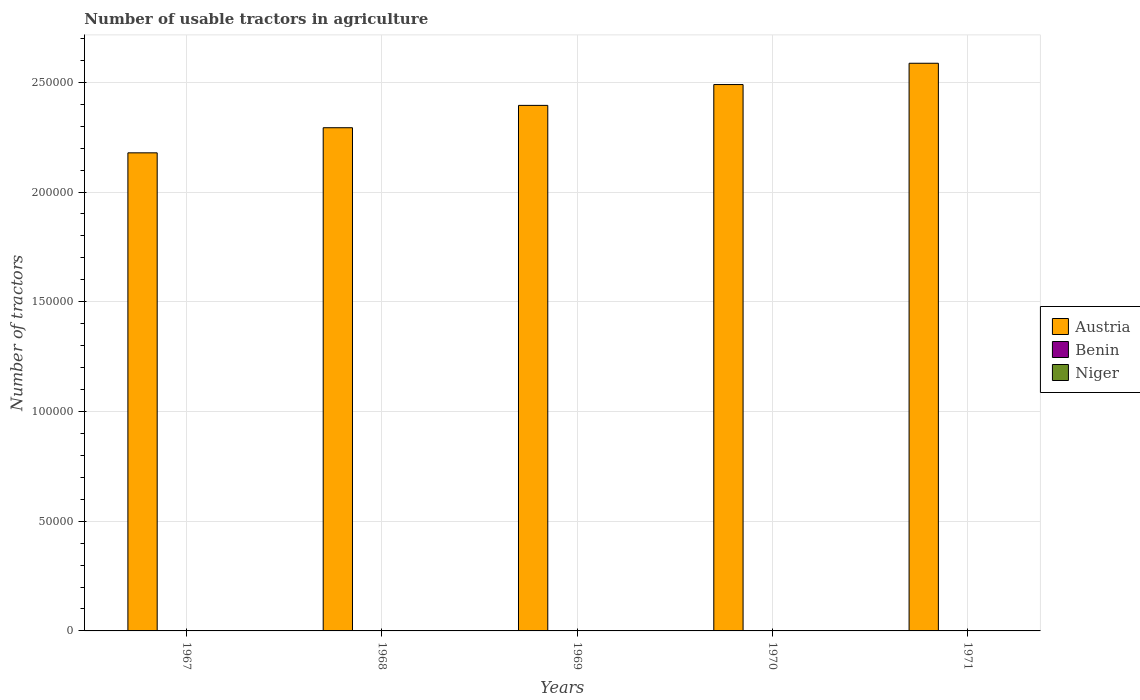How many groups of bars are there?
Make the answer very short. 5. Are the number of bars on each tick of the X-axis equal?
Your answer should be compact. Yes. How many bars are there on the 3rd tick from the right?
Give a very brief answer. 3. In how many cases, is the number of bars for a given year not equal to the number of legend labels?
Offer a very short reply. 0. What is the number of usable tractors in agriculture in Austria in 1969?
Ensure brevity in your answer.  2.39e+05. Across all years, what is the minimum number of usable tractors in agriculture in Austria?
Provide a short and direct response. 2.18e+05. In which year was the number of usable tractors in agriculture in Austria maximum?
Provide a short and direct response. 1971. In which year was the number of usable tractors in agriculture in Austria minimum?
Offer a very short reply. 1967. What is the total number of usable tractors in agriculture in Austria in the graph?
Give a very brief answer. 1.19e+06. What is the difference between the number of usable tractors in agriculture in Niger in 1969 and that in 1971?
Give a very brief answer. -46. What is the difference between the number of usable tractors in agriculture in Austria in 1969 and the number of usable tractors in agriculture in Benin in 1967?
Offer a very short reply. 2.39e+05. What is the average number of usable tractors in agriculture in Austria per year?
Your answer should be very brief. 2.39e+05. In the year 1969, what is the difference between the number of usable tractors in agriculture in Benin and number of usable tractors in agriculture in Austria?
Provide a short and direct response. -2.39e+05. In how many years, is the number of usable tractors in agriculture in Benin greater than 120000?
Ensure brevity in your answer.  0. What is the ratio of the number of usable tractors in agriculture in Benin in 1970 to that in 1971?
Offer a very short reply. 0.97. Is the number of usable tractors in agriculture in Benin in 1967 less than that in 1969?
Your answer should be very brief. Yes. Is the difference between the number of usable tractors in agriculture in Benin in 1967 and 1970 greater than the difference between the number of usable tractors in agriculture in Austria in 1967 and 1970?
Your answer should be very brief. Yes. What is the difference between the highest and the lowest number of usable tractors in agriculture in Niger?
Your answer should be compact. 48. What does the 1st bar from the left in 1967 represents?
Your answer should be very brief. Austria. Is it the case that in every year, the sum of the number of usable tractors in agriculture in Benin and number of usable tractors in agriculture in Niger is greater than the number of usable tractors in agriculture in Austria?
Offer a very short reply. No. How many bars are there?
Offer a very short reply. 15. Are all the bars in the graph horizontal?
Keep it short and to the point. No. Are the values on the major ticks of Y-axis written in scientific E-notation?
Offer a very short reply. No. Does the graph contain any zero values?
Ensure brevity in your answer.  No. Does the graph contain grids?
Ensure brevity in your answer.  Yes. Where does the legend appear in the graph?
Offer a terse response. Center right. How many legend labels are there?
Provide a succinct answer. 3. How are the legend labels stacked?
Offer a terse response. Vertical. What is the title of the graph?
Offer a terse response. Number of usable tractors in agriculture. What is the label or title of the X-axis?
Provide a short and direct response. Years. What is the label or title of the Y-axis?
Ensure brevity in your answer.  Number of tractors. What is the Number of tractors in Austria in 1967?
Ensure brevity in your answer.  2.18e+05. What is the Number of tractors of Benin in 1967?
Keep it short and to the point. 72. What is the Number of tractors of Niger in 1967?
Provide a short and direct response. 12. What is the Number of tractors of Austria in 1968?
Keep it short and to the point. 2.29e+05. What is the Number of tractors of Benin in 1968?
Offer a terse response. 74. What is the Number of tractors in Austria in 1969?
Keep it short and to the point. 2.39e+05. What is the Number of tractors of Niger in 1969?
Provide a succinct answer. 14. What is the Number of tractors of Austria in 1970?
Give a very brief answer. 2.49e+05. What is the Number of tractors of Benin in 1970?
Provide a succinct answer. 78. What is the Number of tractors in Niger in 1970?
Your answer should be compact. 47. What is the Number of tractors in Austria in 1971?
Offer a terse response. 2.59e+05. What is the Number of tractors of Benin in 1971?
Offer a terse response. 80. What is the Number of tractors of Niger in 1971?
Ensure brevity in your answer.  60. Across all years, what is the maximum Number of tractors in Austria?
Make the answer very short. 2.59e+05. Across all years, what is the minimum Number of tractors in Austria?
Make the answer very short. 2.18e+05. What is the total Number of tractors in Austria in the graph?
Give a very brief answer. 1.19e+06. What is the total Number of tractors of Benin in the graph?
Your response must be concise. 380. What is the total Number of tractors of Niger in the graph?
Give a very brief answer. 147. What is the difference between the Number of tractors of Austria in 1967 and that in 1968?
Offer a terse response. -1.14e+04. What is the difference between the Number of tractors of Austria in 1967 and that in 1969?
Your answer should be very brief. -2.16e+04. What is the difference between the Number of tractors of Austria in 1967 and that in 1970?
Ensure brevity in your answer.  -3.11e+04. What is the difference between the Number of tractors of Benin in 1967 and that in 1970?
Your answer should be very brief. -6. What is the difference between the Number of tractors of Niger in 1967 and that in 1970?
Give a very brief answer. -35. What is the difference between the Number of tractors of Austria in 1967 and that in 1971?
Your answer should be compact. -4.08e+04. What is the difference between the Number of tractors in Benin in 1967 and that in 1971?
Ensure brevity in your answer.  -8. What is the difference between the Number of tractors of Niger in 1967 and that in 1971?
Your response must be concise. -48. What is the difference between the Number of tractors of Austria in 1968 and that in 1969?
Ensure brevity in your answer.  -1.02e+04. What is the difference between the Number of tractors of Benin in 1968 and that in 1969?
Offer a terse response. -2. What is the difference between the Number of tractors in Austria in 1968 and that in 1970?
Give a very brief answer. -1.97e+04. What is the difference between the Number of tractors of Benin in 1968 and that in 1970?
Your answer should be compact. -4. What is the difference between the Number of tractors in Niger in 1968 and that in 1970?
Your answer should be compact. -33. What is the difference between the Number of tractors in Austria in 1968 and that in 1971?
Make the answer very short. -2.94e+04. What is the difference between the Number of tractors in Niger in 1968 and that in 1971?
Make the answer very short. -46. What is the difference between the Number of tractors in Austria in 1969 and that in 1970?
Offer a terse response. -9494. What is the difference between the Number of tractors in Niger in 1969 and that in 1970?
Give a very brief answer. -33. What is the difference between the Number of tractors in Austria in 1969 and that in 1971?
Make the answer very short. -1.92e+04. What is the difference between the Number of tractors in Niger in 1969 and that in 1971?
Your response must be concise. -46. What is the difference between the Number of tractors of Austria in 1970 and that in 1971?
Ensure brevity in your answer.  -9704. What is the difference between the Number of tractors of Benin in 1970 and that in 1971?
Offer a very short reply. -2. What is the difference between the Number of tractors of Austria in 1967 and the Number of tractors of Benin in 1968?
Offer a terse response. 2.18e+05. What is the difference between the Number of tractors in Austria in 1967 and the Number of tractors in Niger in 1968?
Offer a very short reply. 2.18e+05. What is the difference between the Number of tractors of Benin in 1967 and the Number of tractors of Niger in 1968?
Provide a succinct answer. 58. What is the difference between the Number of tractors of Austria in 1967 and the Number of tractors of Benin in 1969?
Provide a short and direct response. 2.18e+05. What is the difference between the Number of tractors of Austria in 1967 and the Number of tractors of Niger in 1969?
Provide a succinct answer. 2.18e+05. What is the difference between the Number of tractors in Austria in 1967 and the Number of tractors in Benin in 1970?
Provide a short and direct response. 2.18e+05. What is the difference between the Number of tractors of Austria in 1967 and the Number of tractors of Niger in 1970?
Offer a very short reply. 2.18e+05. What is the difference between the Number of tractors of Austria in 1967 and the Number of tractors of Benin in 1971?
Offer a very short reply. 2.18e+05. What is the difference between the Number of tractors in Austria in 1967 and the Number of tractors in Niger in 1971?
Offer a terse response. 2.18e+05. What is the difference between the Number of tractors in Benin in 1967 and the Number of tractors in Niger in 1971?
Your answer should be compact. 12. What is the difference between the Number of tractors of Austria in 1968 and the Number of tractors of Benin in 1969?
Ensure brevity in your answer.  2.29e+05. What is the difference between the Number of tractors of Austria in 1968 and the Number of tractors of Niger in 1969?
Provide a succinct answer. 2.29e+05. What is the difference between the Number of tractors of Benin in 1968 and the Number of tractors of Niger in 1969?
Make the answer very short. 60. What is the difference between the Number of tractors of Austria in 1968 and the Number of tractors of Benin in 1970?
Your response must be concise. 2.29e+05. What is the difference between the Number of tractors of Austria in 1968 and the Number of tractors of Niger in 1970?
Your answer should be very brief. 2.29e+05. What is the difference between the Number of tractors in Austria in 1968 and the Number of tractors in Benin in 1971?
Keep it short and to the point. 2.29e+05. What is the difference between the Number of tractors in Austria in 1968 and the Number of tractors in Niger in 1971?
Your answer should be very brief. 2.29e+05. What is the difference between the Number of tractors in Austria in 1969 and the Number of tractors in Benin in 1970?
Give a very brief answer. 2.39e+05. What is the difference between the Number of tractors in Austria in 1969 and the Number of tractors in Niger in 1970?
Your answer should be very brief. 2.39e+05. What is the difference between the Number of tractors of Austria in 1969 and the Number of tractors of Benin in 1971?
Provide a short and direct response. 2.39e+05. What is the difference between the Number of tractors of Austria in 1969 and the Number of tractors of Niger in 1971?
Keep it short and to the point. 2.39e+05. What is the difference between the Number of tractors of Austria in 1970 and the Number of tractors of Benin in 1971?
Give a very brief answer. 2.49e+05. What is the difference between the Number of tractors in Austria in 1970 and the Number of tractors in Niger in 1971?
Your answer should be very brief. 2.49e+05. What is the difference between the Number of tractors of Benin in 1970 and the Number of tractors of Niger in 1971?
Your answer should be very brief. 18. What is the average Number of tractors of Austria per year?
Offer a terse response. 2.39e+05. What is the average Number of tractors of Niger per year?
Give a very brief answer. 29.4. In the year 1967, what is the difference between the Number of tractors of Austria and Number of tractors of Benin?
Ensure brevity in your answer.  2.18e+05. In the year 1967, what is the difference between the Number of tractors of Austria and Number of tractors of Niger?
Your response must be concise. 2.18e+05. In the year 1968, what is the difference between the Number of tractors in Austria and Number of tractors in Benin?
Make the answer very short. 2.29e+05. In the year 1968, what is the difference between the Number of tractors of Austria and Number of tractors of Niger?
Offer a terse response. 2.29e+05. In the year 1969, what is the difference between the Number of tractors in Austria and Number of tractors in Benin?
Make the answer very short. 2.39e+05. In the year 1969, what is the difference between the Number of tractors of Austria and Number of tractors of Niger?
Make the answer very short. 2.39e+05. In the year 1969, what is the difference between the Number of tractors in Benin and Number of tractors in Niger?
Ensure brevity in your answer.  62. In the year 1970, what is the difference between the Number of tractors in Austria and Number of tractors in Benin?
Provide a short and direct response. 2.49e+05. In the year 1970, what is the difference between the Number of tractors in Austria and Number of tractors in Niger?
Your answer should be very brief. 2.49e+05. In the year 1971, what is the difference between the Number of tractors in Austria and Number of tractors in Benin?
Your answer should be very brief. 2.59e+05. In the year 1971, what is the difference between the Number of tractors in Austria and Number of tractors in Niger?
Give a very brief answer. 2.59e+05. What is the ratio of the Number of tractors of Austria in 1967 to that in 1968?
Ensure brevity in your answer.  0.95. What is the ratio of the Number of tractors of Austria in 1967 to that in 1969?
Offer a terse response. 0.91. What is the ratio of the Number of tractors in Benin in 1967 to that in 1969?
Provide a short and direct response. 0.95. What is the ratio of the Number of tractors in Niger in 1967 to that in 1969?
Keep it short and to the point. 0.86. What is the ratio of the Number of tractors of Benin in 1967 to that in 1970?
Your answer should be compact. 0.92. What is the ratio of the Number of tractors in Niger in 1967 to that in 1970?
Give a very brief answer. 0.26. What is the ratio of the Number of tractors of Austria in 1967 to that in 1971?
Provide a short and direct response. 0.84. What is the ratio of the Number of tractors of Benin in 1967 to that in 1971?
Keep it short and to the point. 0.9. What is the ratio of the Number of tractors in Austria in 1968 to that in 1969?
Provide a short and direct response. 0.96. What is the ratio of the Number of tractors in Benin in 1968 to that in 1969?
Ensure brevity in your answer.  0.97. What is the ratio of the Number of tractors of Niger in 1968 to that in 1969?
Your answer should be very brief. 1. What is the ratio of the Number of tractors of Austria in 1968 to that in 1970?
Ensure brevity in your answer.  0.92. What is the ratio of the Number of tractors in Benin in 1968 to that in 1970?
Make the answer very short. 0.95. What is the ratio of the Number of tractors in Niger in 1968 to that in 1970?
Your answer should be very brief. 0.3. What is the ratio of the Number of tractors in Austria in 1968 to that in 1971?
Make the answer very short. 0.89. What is the ratio of the Number of tractors in Benin in 1968 to that in 1971?
Your answer should be very brief. 0.93. What is the ratio of the Number of tractors of Niger in 1968 to that in 1971?
Keep it short and to the point. 0.23. What is the ratio of the Number of tractors in Austria in 1969 to that in 1970?
Provide a short and direct response. 0.96. What is the ratio of the Number of tractors in Benin in 1969 to that in 1970?
Provide a succinct answer. 0.97. What is the ratio of the Number of tractors of Niger in 1969 to that in 1970?
Offer a very short reply. 0.3. What is the ratio of the Number of tractors in Austria in 1969 to that in 1971?
Make the answer very short. 0.93. What is the ratio of the Number of tractors in Benin in 1969 to that in 1971?
Give a very brief answer. 0.95. What is the ratio of the Number of tractors of Niger in 1969 to that in 1971?
Your answer should be very brief. 0.23. What is the ratio of the Number of tractors in Austria in 1970 to that in 1971?
Your response must be concise. 0.96. What is the ratio of the Number of tractors in Niger in 1970 to that in 1971?
Your answer should be very brief. 0.78. What is the difference between the highest and the second highest Number of tractors in Austria?
Make the answer very short. 9704. What is the difference between the highest and the lowest Number of tractors in Austria?
Your response must be concise. 4.08e+04. What is the difference between the highest and the lowest Number of tractors of Niger?
Offer a terse response. 48. 